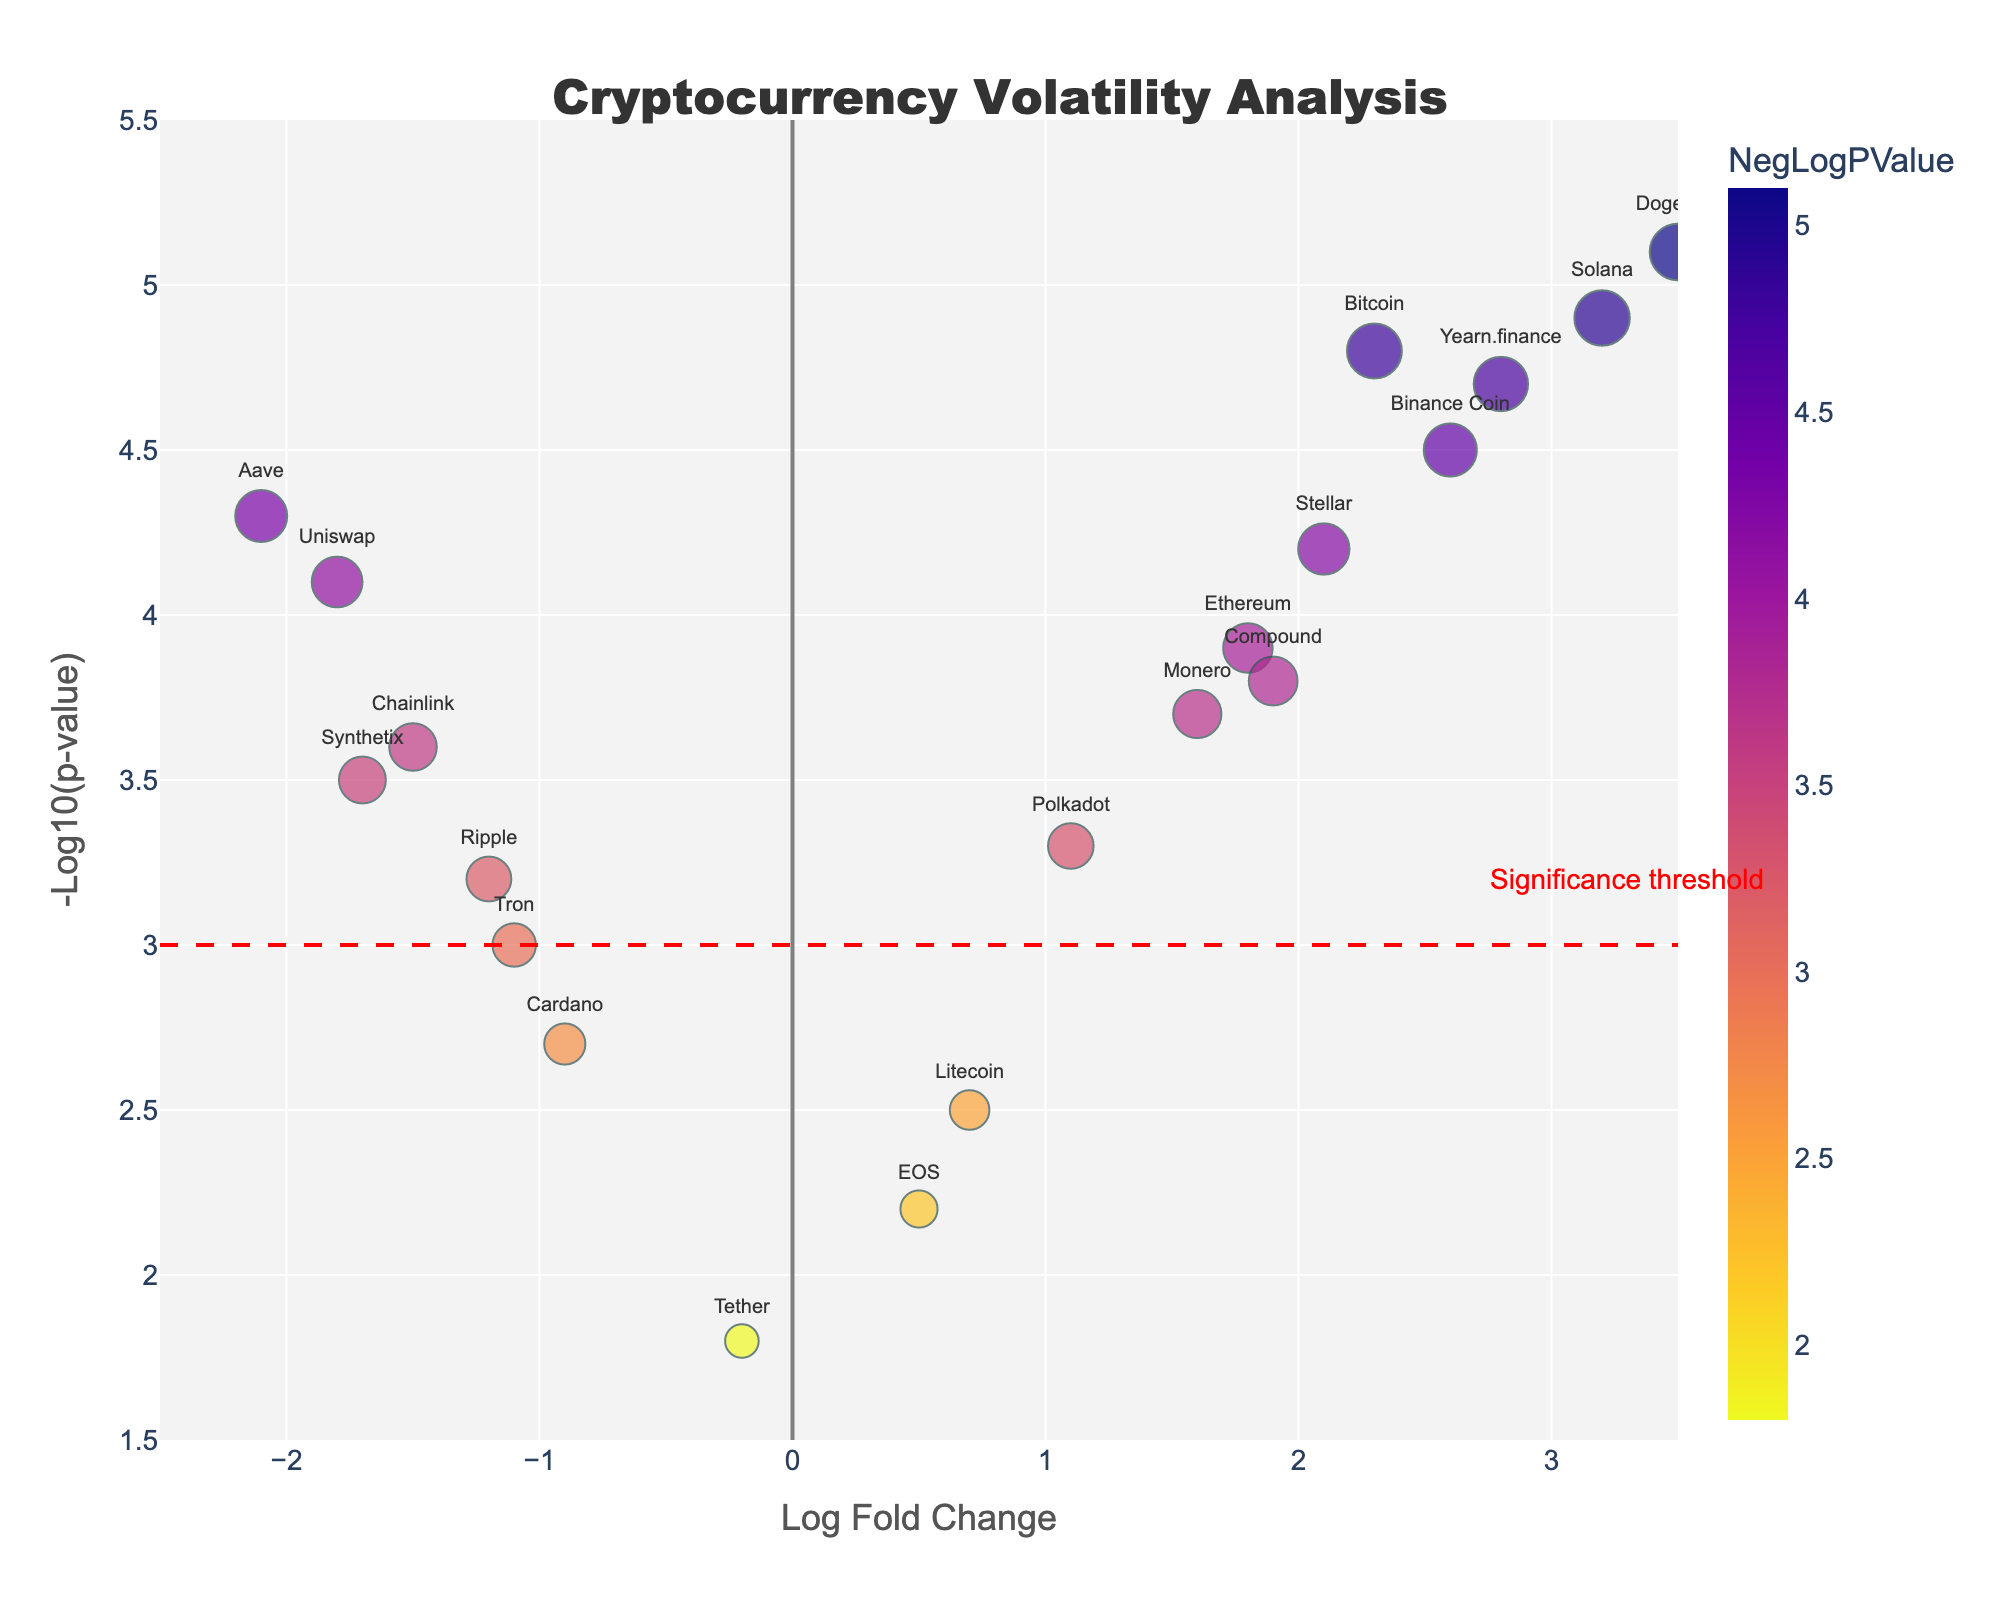What is the title of the plot? The title is typically at the top of the plot, and it clearly states what the plot represents. Here, the title is "Cryptocurrency Volatility Analysis".
Answer: Cryptocurrency Volatility Analysis What do the x-axis and y-axis represent? The axes labels are part of the plot layout. The x-axis is labeled "Log Fold Change" and the y-axis is labeled "-Log10(p-value)", indicating the representation of data.
Answer: Log Fold Change and -Log10(p-value) How many coins show a significant price movement (NegLogPValue > 3)? In the plot, coins with NegLogPValue greater than 3 are above the red dashed line. By counting these coins, we see that there are 13 such coins.
Answer: 13 Which coin has the highest Log Fold Change? By looking at the data points on the x-axis, we identify the coin furthest to the right. Here, Dogecoin has the highest Log Fold Change value of 3.5.
Answer: Dogecoin Which coin has the most extreme negative Log Fold Change? The coin furthest to the left on the x-axis represents the most extreme negative Log Fold Change. Aave, with a Log Fold Change of -2.1, is the furthest left.
Answer: Aave How many coins have a positive Log Fold Change and a NegLogPValue greater than 4? To answer this, we look for data points to the right of the vertical line where x=0 and above the horizontal line where y=4. There are 5 such coins: Bitcoin, Dogecoin, Stellar, Solana, and Yearn.finance.
Answer: 5 What is the significance threshold as indicated on the plot? The significance threshold line is annotated and represented by the dashed red line at NegLogPValue = 3.
Answer: NegLogPValue = 3 Compare the price movements of Binance Coin and Uniswap. Which one is more significant and how do their Log Fold Changes compare? Binance Coin (2.6, 4.5) has a higher fold change and a more significant movement compared to Uniswap (-1.8, 4.1). The higher NegLogPValue and positive Log Fold Change of Binance Coin indicate a more significant positive price movement.
Answer: Binance Coin is more significant, and it has a more positive Log Fold Change Among Ethereum and Ripple, which has more significant price fluctuation? Ethereum has a NegLogPValue of 3.9, while Ripple has a NegLogPValue of 3.2. Since higher NegLogPValue indicates higher significance, Ethereum shows a more significant price fluctuation than Ripple.
Answer: Ethereum 